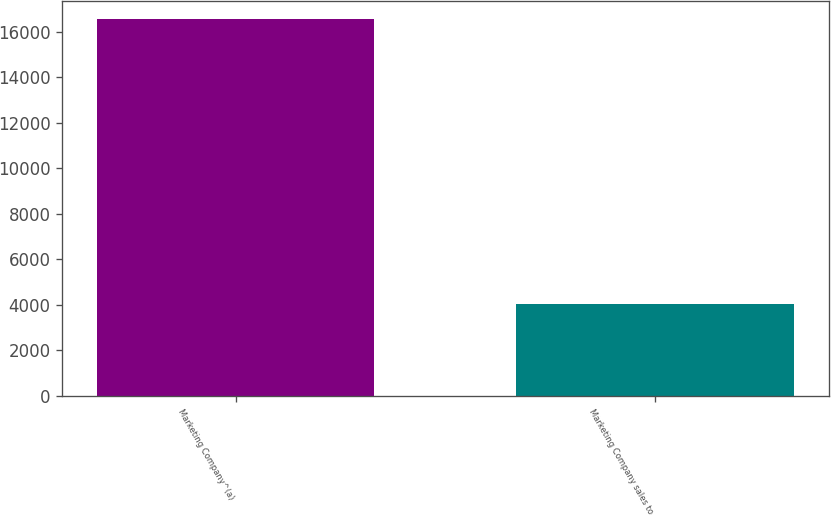Convert chart. <chart><loc_0><loc_0><loc_500><loc_500><bar_chart><fcel>Marketing Company^(a)<fcel>Marketing Company sales to<nl><fcel>16551<fcel>4037.4<nl></chart> 